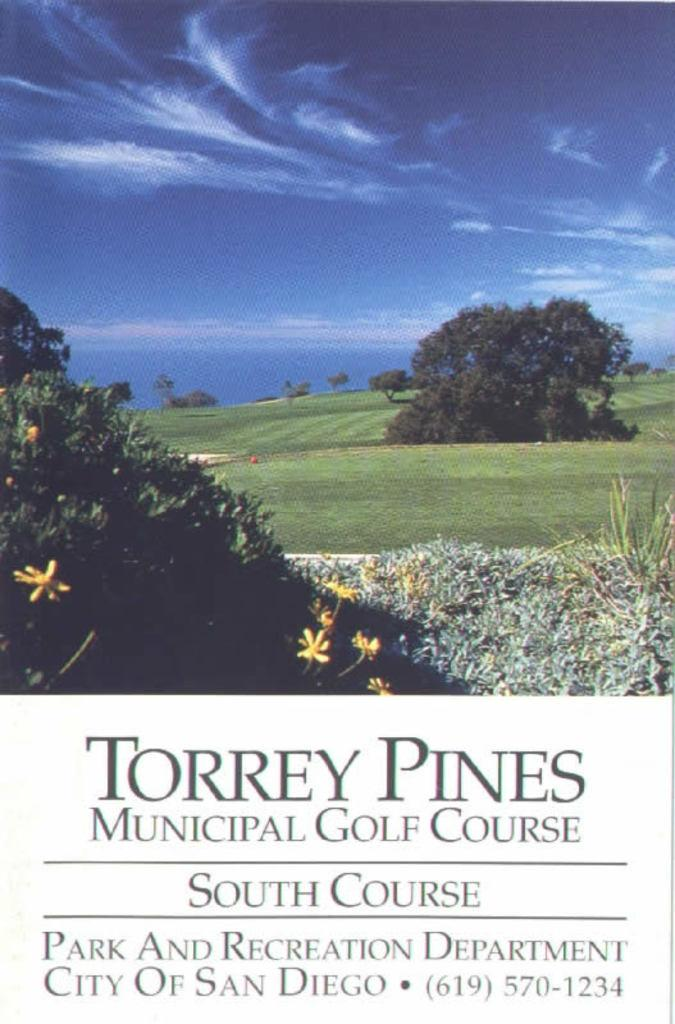What is featured on the poster in the image? The poster contains images of trees and grass. Are there any words on the poster? Yes, there is text on the poster. How many balls can be seen on the poster? There are no balls present on the poster; it features images of trees and grass. What type of needle is used to create the text on the poster? There is no needle used to create the text on the poster; it is likely printed or handwritten. 